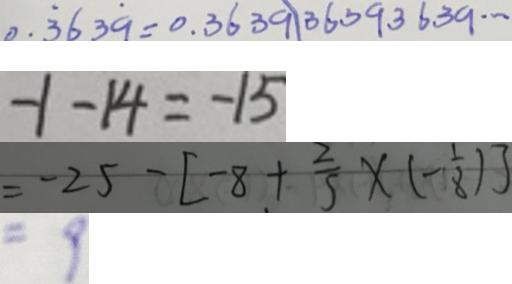<formula> <loc_0><loc_0><loc_500><loc_500>0 . \dot { 3 } 6 3 \dot { 9 } = 0 . 3 6 3 9 1 3 6 3 9 3 6 3 9 \cdots 
 - 1 - 1 4 = - 1 5 
 = - 2 5 - [ - 8 + \frac { 2 } { 5 } \times ( - \frac { 1 } { 8 } ) ] 
 = 9</formula> 